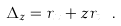<formula> <loc_0><loc_0><loc_500><loc_500>\Delta _ { z } = r _ { x } + z r _ { t } \ .</formula> 